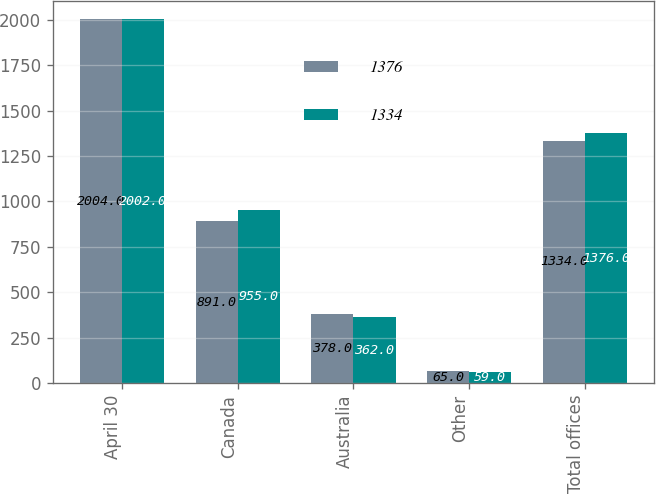<chart> <loc_0><loc_0><loc_500><loc_500><stacked_bar_chart><ecel><fcel>April 30<fcel>Canada<fcel>Australia<fcel>Other<fcel>Total offices<nl><fcel>1376<fcel>2004<fcel>891<fcel>378<fcel>65<fcel>1334<nl><fcel>1334<fcel>2002<fcel>955<fcel>362<fcel>59<fcel>1376<nl></chart> 